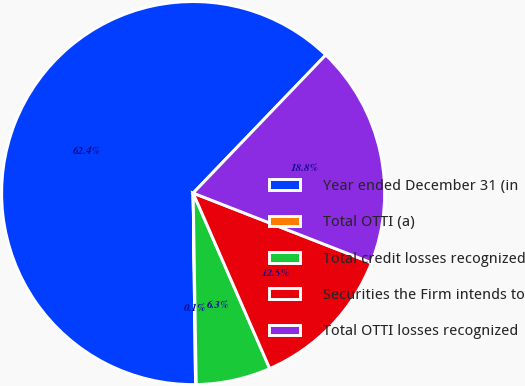<chart> <loc_0><loc_0><loc_500><loc_500><pie_chart><fcel>Year ended December 31 (in<fcel>Total OTTI (a)<fcel>Total credit losses recognized<fcel>Securities the Firm intends to<fcel>Total OTTI losses recognized<nl><fcel>62.37%<fcel>0.06%<fcel>6.29%<fcel>12.52%<fcel>18.75%<nl></chart> 